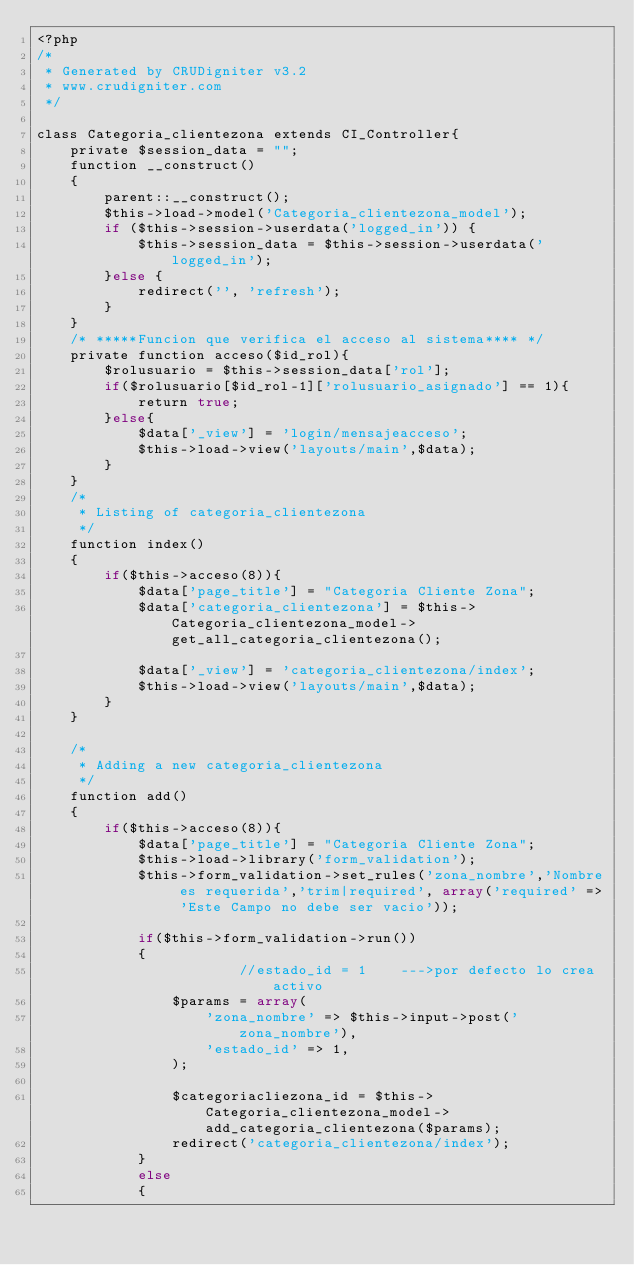Convert code to text. <code><loc_0><loc_0><loc_500><loc_500><_PHP_><?php
/* 
 * Generated by CRUDigniter v3.2 
 * www.crudigniter.com
 */
 
class Categoria_clientezona extends CI_Controller{
    private $session_data = "";
    function __construct()
    {
        parent::__construct();
        $this->load->model('Categoria_clientezona_model');
        if ($this->session->userdata('logged_in')) {
            $this->session_data = $this->session->userdata('logged_in');
        }else {
            redirect('', 'refresh');
        }
    }
    /* *****Funcion que verifica el acceso al sistema**** */
    private function acceso($id_rol){
        $rolusuario = $this->session_data['rol'];
        if($rolusuario[$id_rol-1]['rolusuario_asignado'] == 1){
            return true;
        }else{
            $data['_view'] = 'login/mensajeacceso';
            $this->load->view('layouts/main',$data);
        }
    }
    /*
     * Listing of categoria_clientezona
     */
    function index()
    {
        if($this->acceso(8)){
            $data['page_title'] = "Categoria Cliente Zona";
            $data['categoria_clientezona'] = $this->Categoria_clientezona_model->get_all_categoria_clientezona();

            $data['_view'] = 'categoria_clientezona/index';
            $this->load->view('layouts/main',$data);
        }
    }

    /*
     * Adding a new categoria_clientezona
     */
    function add()
    {   
        if($this->acceso(8)){
            $data['page_title'] = "Categoria Cliente Zona";
            $this->load->library('form_validation');
            $this->form_validation->set_rules('zona_nombre','Nombre es requerida','trim|required', array('required' => 'Este Campo no debe ser vacio'));

            if($this->form_validation->run())     
            {
                        //estado_id = 1    --->por defecto lo crea activo
                $params = array(
                    'zona_nombre' => $this->input->post('zona_nombre'),
                    'estado_id' => 1,
                );

                $categoriacliezona_id = $this->Categoria_clientezona_model->add_categoria_clientezona($params);
                redirect('categoria_clientezona/index');
            }
            else
            {</code> 